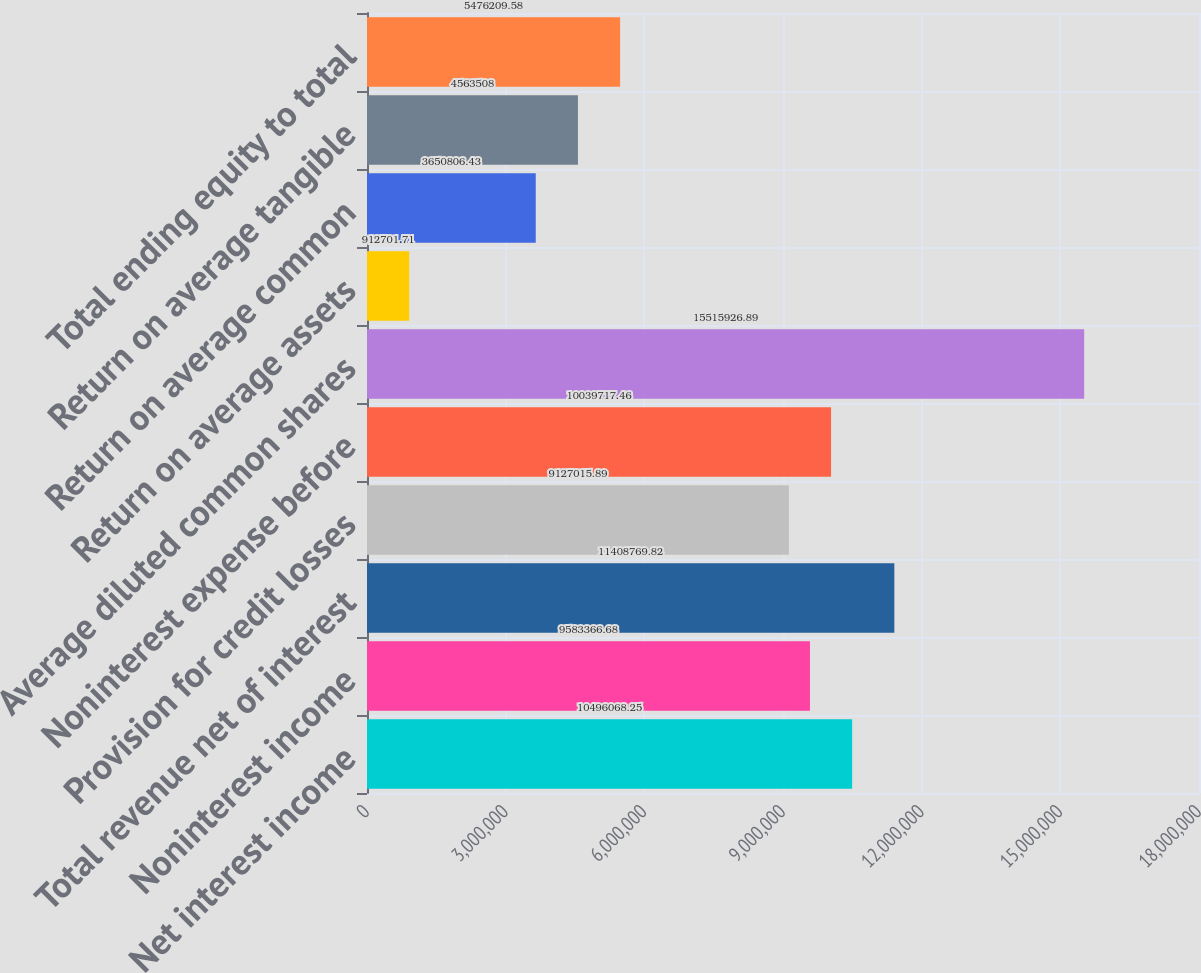Convert chart. <chart><loc_0><loc_0><loc_500><loc_500><bar_chart><fcel>Net interest income<fcel>Noninterest income<fcel>Total revenue net of interest<fcel>Provision for credit losses<fcel>Noninterest expense before<fcel>Average diluted common shares<fcel>Return on average assets<fcel>Return on average common<fcel>Return on average tangible<fcel>Total ending equity to total<nl><fcel>1.04961e+07<fcel>9.58337e+06<fcel>1.14088e+07<fcel>9.12702e+06<fcel>1.00397e+07<fcel>1.55159e+07<fcel>912702<fcel>3.65081e+06<fcel>4.56351e+06<fcel>5.47621e+06<nl></chart> 